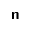Convert formula to latex. <formula><loc_0><loc_0><loc_500><loc_500>\mathsf n</formula> 